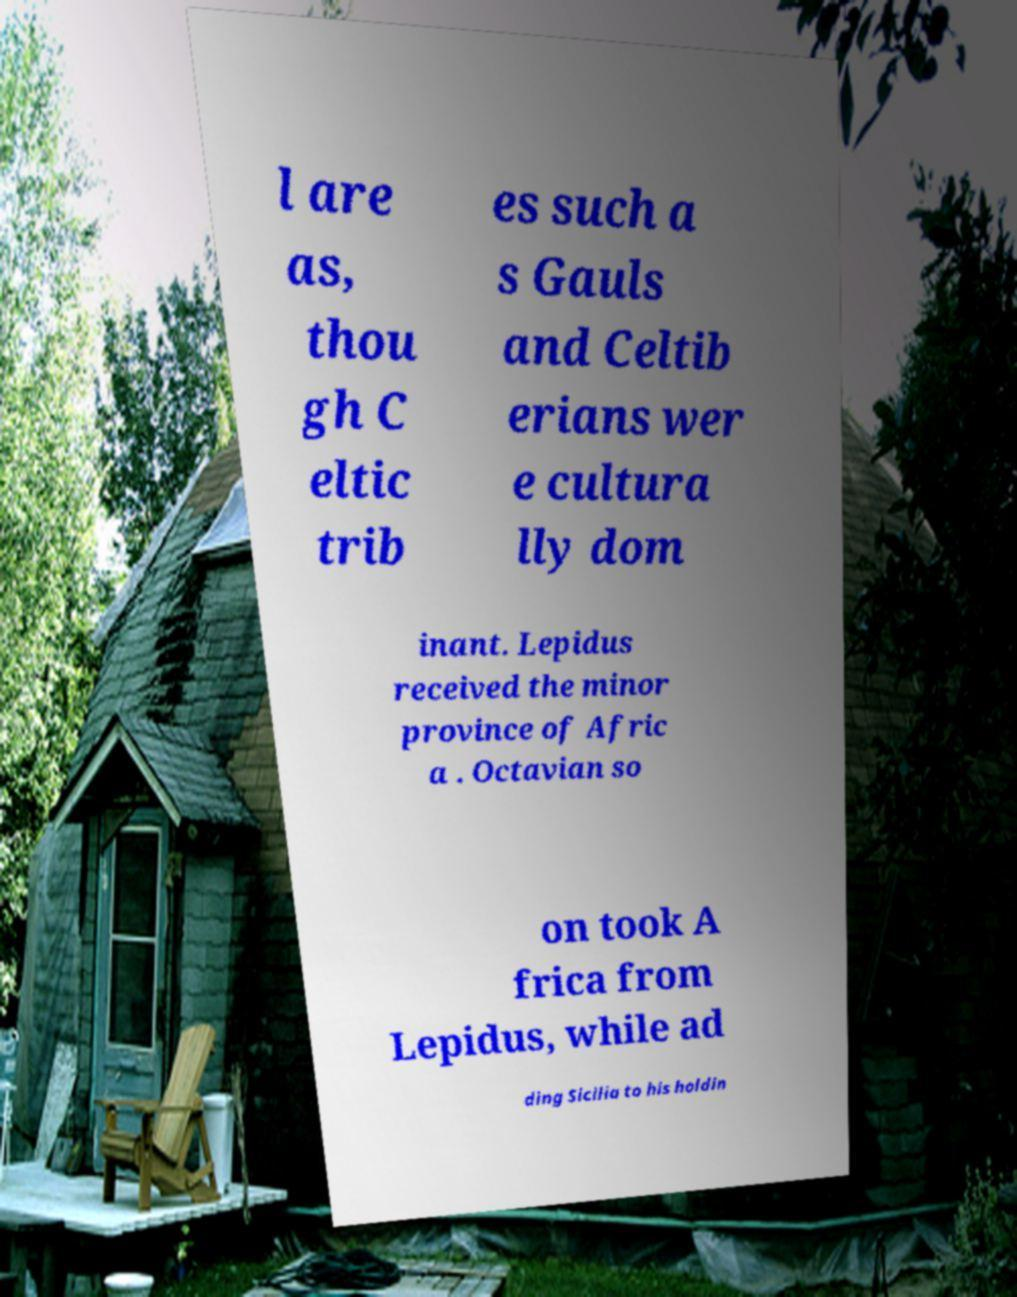Please read and relay the text visible in this image. What does it say? l are as, thou gh C eltic trib es such a s Gauls and Celtib erians wer e cultura lly dom inant. Lepidus received the minor province of Afric a . Octavian so on took A frica from Lepidus, while ad ding Sicilia to his holdin 